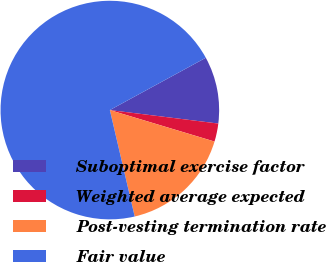Convert chart to OTSL. <chart><loc_0><loc_0><loc_500><loc_500><pie_chart><fcel>Suboptimal exercise factor<fcel>Weighted average expected<fcel>Post-vesting termination rate<fcel>Fair value<nl><fcel>9.91%<fcel>2.68%<fcel>16.7%<fcel>70.7%<nl></chart> 